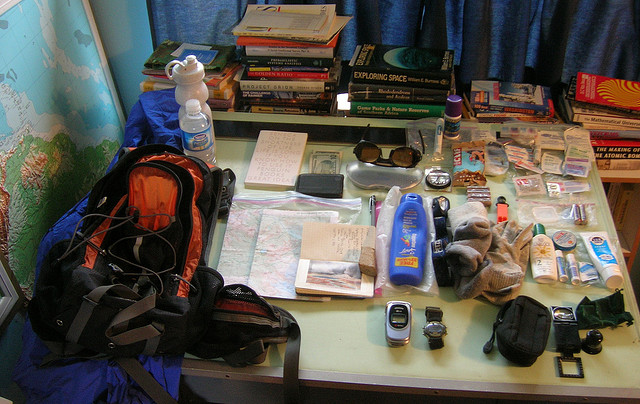Describe the books that are laid out on the table. There's a diverse collection of books that seem to focus on travel and adventure. They include titles on space exploration, what could be guides or narratives related to travel, and some other literature which isn't distinctly visible from this angle. 